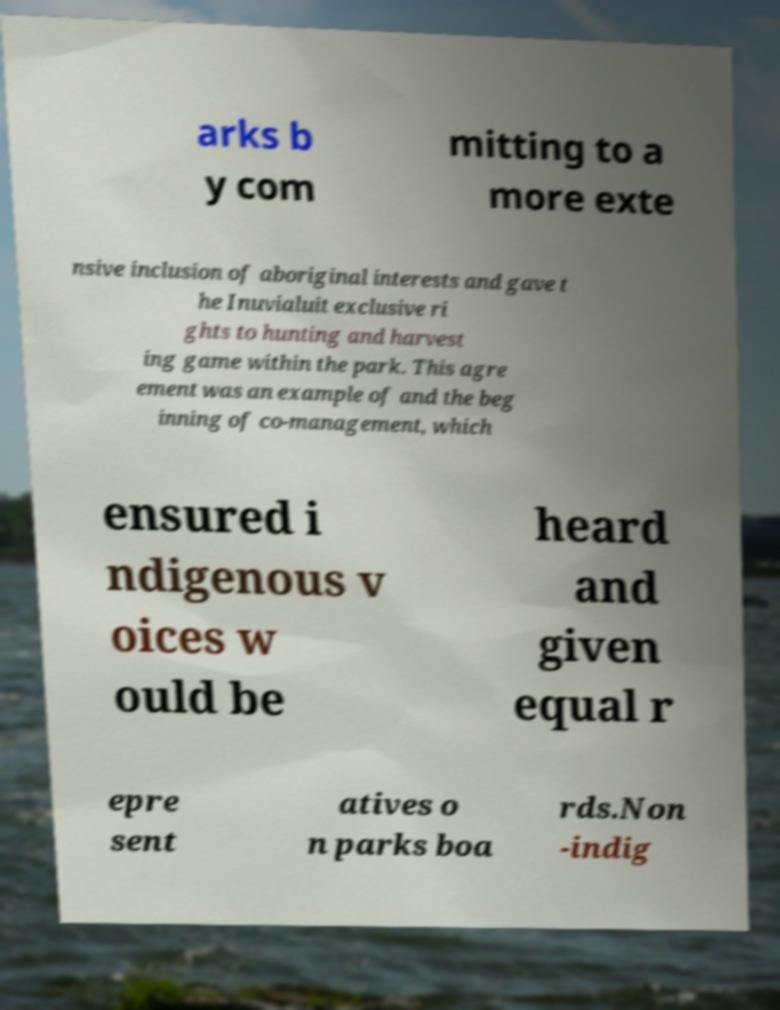For documentation purposes, I need the text within this image transcribed. Could you provide that? arks b y com mitting to a more exte nsive inclusion of aboriginal interests and gave t he Inuvialuit exclusive ri ghts to hunting and harvest ing game within the park. This agre ement was an example of and the beg inning of co-management, which ensured i ndigenous v oices w ould be heard and given equal r epre sent atives o n parks boa rds.Non -indig 